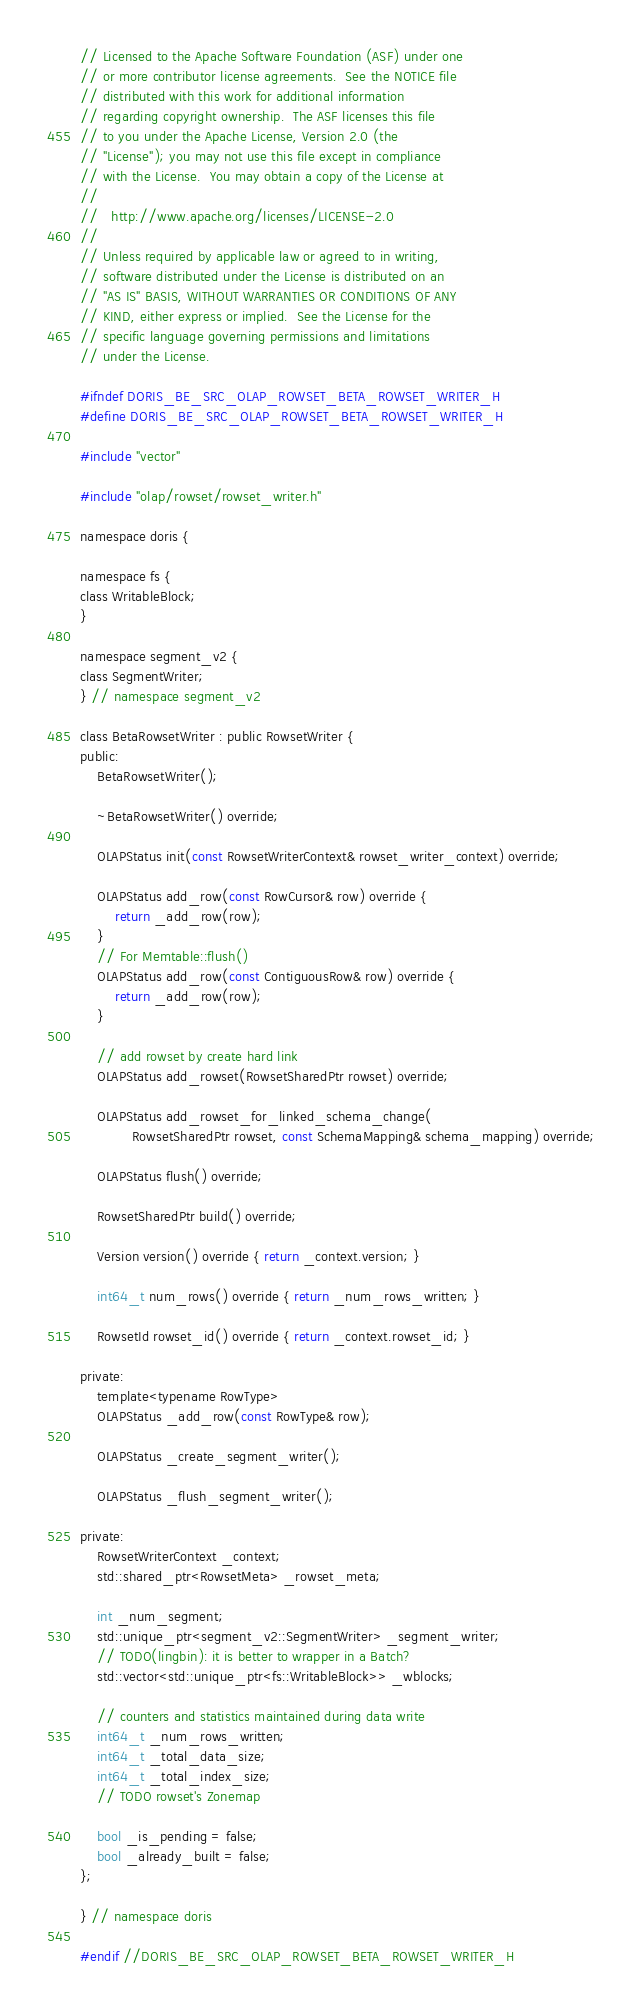Convert code to text. <code><loc_0><loc_0><loc_500><loc_500><_C_>// Licensed to the Apache Software Foundation (ASF) under one
// or more contributor license agreements.  See the NOTICE file
// distributed with this work for additional information
// regarding copyright ownership.  The ASF licenses this file
// to you under the Apache License, Version 2.0 (the
// "License"); you may not use this file except in compliance
// with the License.  You may obtain a copy of the License at
//
//   http://www.apache.org/licenses/LICENSE-2.0
//
// Unless required by applicable law or agreed to in writing,
// software distributed under the License is distributed on an
// "AS IS" BASIS, WITHOUT WARRANTIES OR CONDITIONS OF ANY
// KIND, either express or implied.  See the License for the
// specific language governing permissions and limitations
// under the License.

#ifndef DORIS_BE_SRC_OLAP_ROWSET_BETA_ROWSET_WRITER_H
#define DORIS_BE_SRC_OLAP_ROWSET_BETA_ROWSET_WRITER_H

#include "vector"

#include "olap/rowset/rowset_writer.h"

namespace doris {

namespace fs {
class WritableBlock;
}

namespace segment_v2 {
class SegmentWriter;
} // namespace segment_v2

class BetaRowsetWriter : public RowsetWriter {
public:
    BetaRowsetWriter();

    ~BetaRowsetWriter() override;

    OLAPStatus init(const RowsetWriterContext& rowset_writer_context) override;

    OLAPStatus add_row(const RowCursor& row) override {
        return _add_row(row);
    }
    // For Memtable::flush()
    OLAPStatus add_row(const ContiguousRow& row) override {
        return _add_row(row);
    }

    // add rowset by create hard link
    OLAPStatus add_rowset(RowsetSharedPtr rowset) override;

    OLAPStatus add_rowset_for_linked_schema_change(
            RowsetSharedPtr rowset, const SchemaMapping& schema_mapping) override;

    OLAPStatus flush() override;

    RowsetSharedPtr build() override;

    Version version() override { return _context.version; }

    int64_t num_rows() override { return _num_rows_written; }

    RowsetId rowset_id() override { return _context.rowset_id; }

private:
    template<typename RowType>
    OLAPStatus _add_row(const RowType& row);

    OLAPStatus _create_segment_writer();

    OLAPStatus _flush_segment_writer();

private:
    RowsetWriterContext _context;
    std::shared_ptr<RowsetMeta> _rowset_meta;

    int _num_segment;
    std::unique_ptr<segment_v2::SegmentWriter> _segment_writer;
    // TODO(lingbin): it is better to wrapper in a Batch?
    std::vector<std::unique_ptr<fs::WritableBlock>> _wblocks;

    // counters and statistics maintained during data write
    int64_t _num_rows_written;
    int64_t _total_data_size;
    int64_t _total_index_size;
    // TODO rowset's Zonemap

    bool _is_pending = false;
    bool _already_built = false;
};

} // namespace doris

#endif //DORIS_BE_SRC_OLAP_ROWSET_BETA_ROWSET_WRITER_H
</code> 